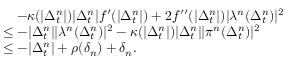Convert formula to latex. <formula><loc_0><loc_0><loc_500><loc_500>\begin{array} { r l } & { \quad - \kappa ( | \Delta _ { t } ^ { n } | ) | \Delta _ { t } ^ { n } | f ^ { \prime } ( | \Delta _ { t } ^ { n } | ) + 2 f ^ { \prime \prime } ( | \Delta _ { t } ^ { n } | ) | \lambda ^ { n } ( \Delta _ { t } ^ { n } ) | ^ { 2 } } \\ & { \leq - | \Delta _ { t } ^ { n } | | \lambda ^ { n } ( \Delta _ { t } ^ { n } ) | ^ { 2 } - \kappa ( | \Delta _ { t } ^ { n } | ) | \Delta _ { t } ^ { n } | | \pi ^ { n } ( \Delta _ { t } ^ { n } ) | ^ { 2 } } \\ & { \leq - | \Delta _ { t } ^ { n } | + \rho ( \delta _ { n } ) + \delta _ { n } . } \end{array}</formula> 